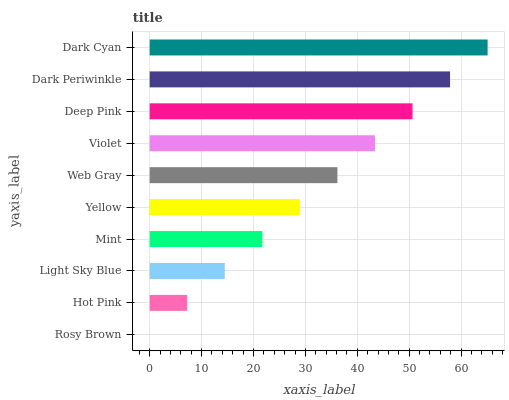Is Rosy Brown the minimum?
Answer yes or no. Yes. Is Dark Cyan the maximum?
Answer yes or no. Yes. Is Hot Pink the minimum?
Answer yes or no. No. Is Hot Pink the maximum?
Answer yes or no. No. Is Hot Pink greater than Rosy Brown?
Answer yes or no. Yes. Is Rosy Brown less than Hot Pink?
Answer yes or no. Yes. Is Rosy Brown greater than Hot Pink?
Answer yes or no. No. Is Hot Pink less than Rosy Brown?
Answer yes or no. No. Is Web Gray the high median?
Answer yes or no. Yes. Is Yellow the low median?
Answer yes or no. Yes. Is Dark Periwinkle the high median?
Answer yes or no. No. Is Light Sky Blue the low median?
Answer yes or no. No. 